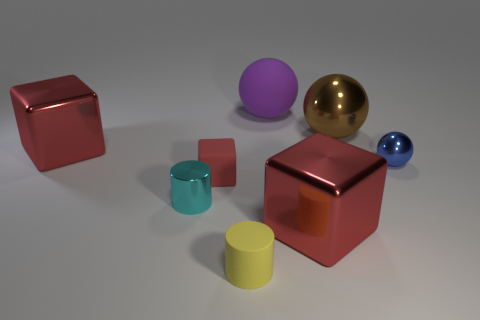The small metal object that is on the left side of the rubber object that is behind the brown thing is what color?
Make the answer very short. Cyan. Is the number of big red objects greater than the number of large rubber spheres?
Offer a very short reply. Yes. How many matte cubes are the same size as the cyan metal object?
Make the answer very short. 1. Are the tiny sphere and the cylinder to the right of the small red block made of the same material?
Offer a terse response. No. Are there fewer red objects than large brown objects?
Provide a succinct answer. No. Is there anything else of the same color as the large matte object?
Your answer should be very brief. No. There is a cyan thing that is made of the same material as the small blue object; what shape is it?
Keep it short and to the point. Cylinder. What number of yellow things are to the left of the big block that is on the left side of the rubber object on the right side of the rubber cylinder?
Provide a short and direct response. 0. There is a tiny object that is left of the large brown metallic ball and behind the tiny cyan cylinder; what shape is it?
Offer a very short reply. Cube. Is the number of blue shiny balls in front of the tiny cyan cylinder less than the number of big red cubes?
Offer a terse response. Yes. 